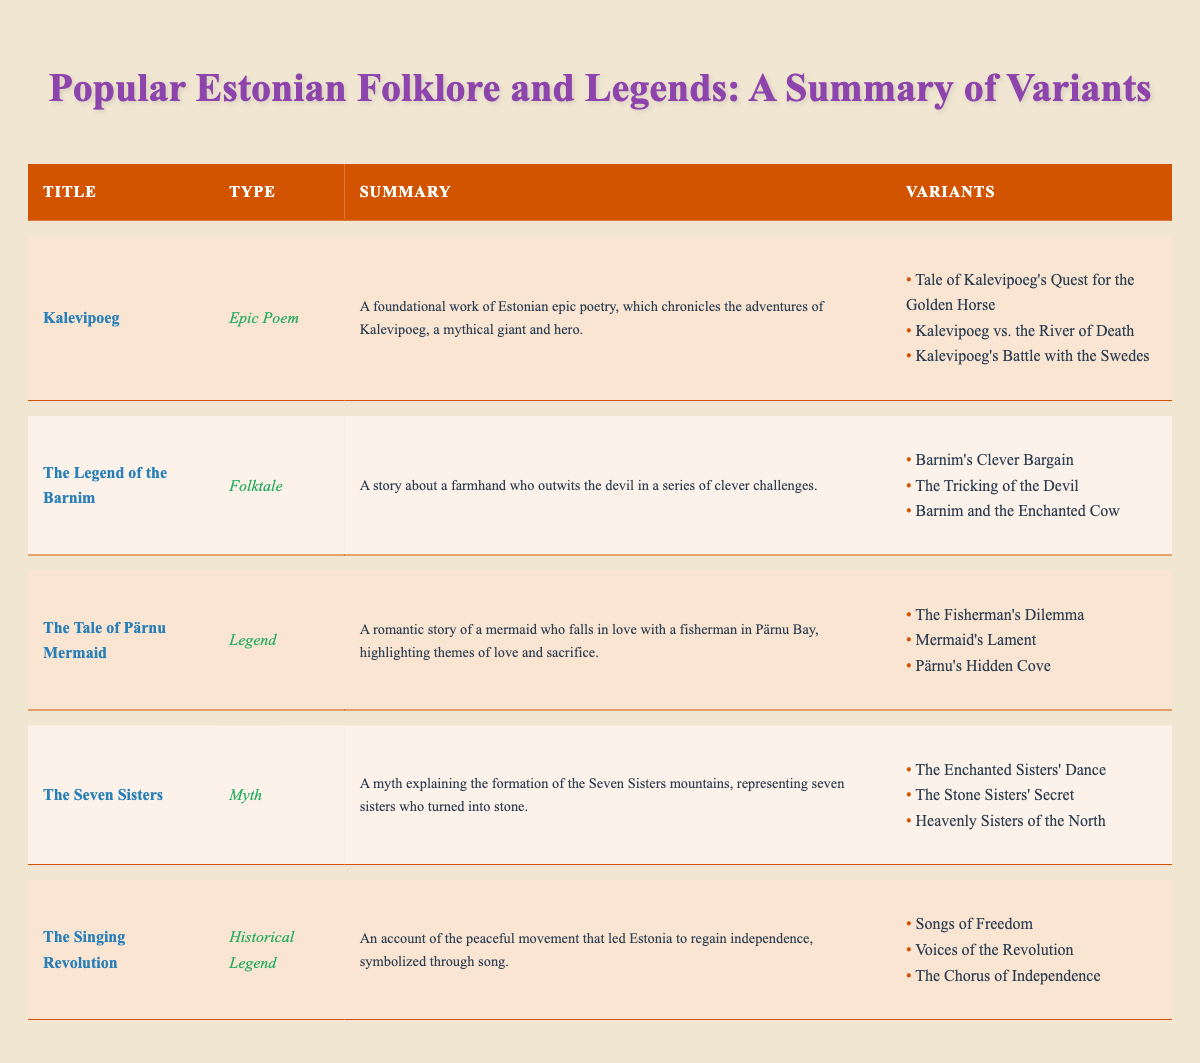What is the title of the epic poem mentioned in the table? The table lists "Kalevipoeg" as the title of the epic poem in the first row.
Answer: Kalevipoeg How many variants are there for "The Tale of Pärnu Mermaid"? Referring to the entry for "The Tale of Pärnu Mermaid," there are three variants listed under that title.
Answer: 3 Is "The Singing Revolution" classified as a myth? The table states that "The Singing Revolution" is categorized as a Historical Legend, not as a myth, which makes this statement false.
Answer: No What are the themes present in "The Tale of Pärnu Mermaid"? The summary of "The Tale of Pärnu Mermaid" mentions themes of love and sacrifice, which are the key themes identified in the narrative.
Answer: Love and sacrifice Which type of folklore has the most variants mentioned in the table? By examining the number of variants for each entry, "Kalevipoeg," "The Legend of the Barnim," and "The Tale of Pärnu Mermaid" each list three variants, but none has more than that. Thus, they all have the maximum number of variants mentioned.
Answer: Epic Poem, Folktale, and Legend (all have 3 variants) Can you list all the titles of the variants for "Kalevipoeg"? In the entry for "Kalevipoeg," the variants provided are: "Tale of Kalevipoeg's Quest for the Golden Horse," "Kalevipoeg vs. the River of Death," and "Kalevipoeg's Battle with the Swedes."
Answer: Tale of Kalevipoeg's Quest for the Golden Horse, Kalevipoeg vs. the River of Death, Kalevipoeg's Battle with the Swedes What can be inferred about the genre of "The Seven Sisters"? The table indicates that "The Seven Sisters" is classified as a Myth, which suggests it is part of a storyline that explains natural phenomena or cultural beliefs, as myths typically do.
Answer: It is a Myth If you combine the variants of "The Legend of the Barnim" and "The Tale of Pärnu Mermaid," how many total variants do you have? "The Legend of the Barnim" has three variants, and "The Tale of Pärnu Mermaid" also has three variants. Adding these together, 3 + 3 = 6 total variants.
Answer: 6 Which entry includes a story involving outsmarting the devil? Referring to the table, "The Legend of the Barnim" features a story about a farmhand who cleverly outwits the devil, which is specified in its summary.
Answer: The Legend of the Barnim What is the connection between the types of folklore and the themes mentioned in the table? Each type of folklore reflects different themes, such as love and sacrifice in "The Tale of Pärnu Mermaid" (Legend) and freedom in "The Singing Revolution" (Historical Legend), showcasing the cultural context affiliated with each folklore type.
Answer: Themes vary by type Are there any historical legends among the entries? The table confirms that "The Singing Revolution" is classified as a Historical Legend. Therefore, the answer is yes, there is one.
Answer: Yes 